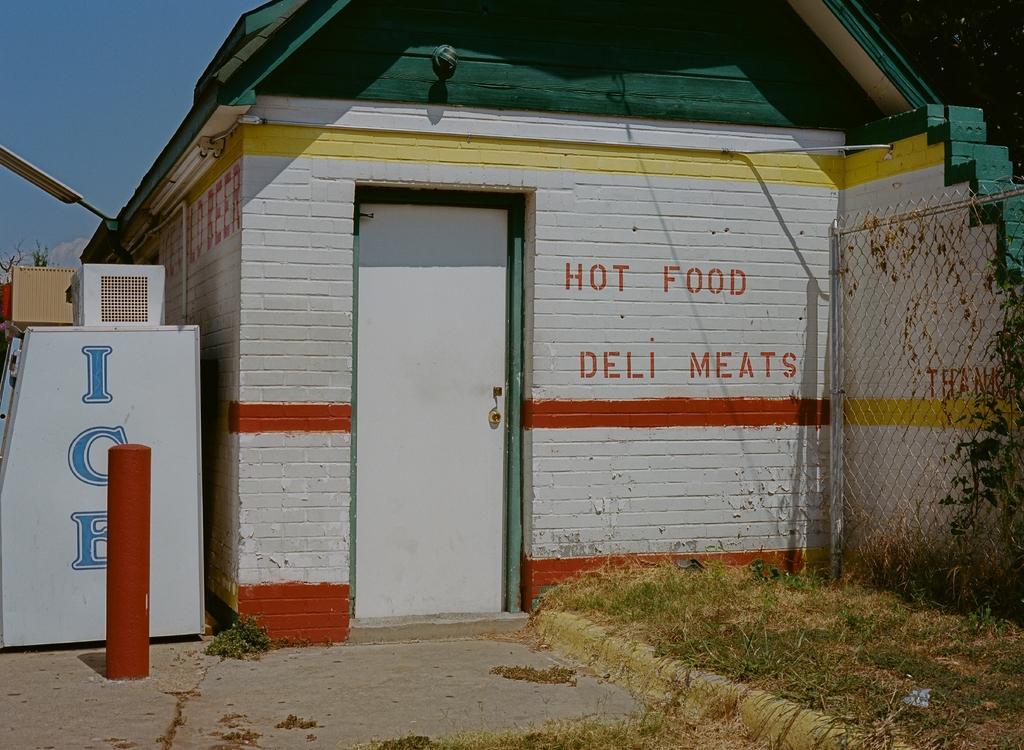Please provide a concise description of this image. In this picture we can see a house and we can find some text on the wall, on the right side of the image we can see fence and grass. 